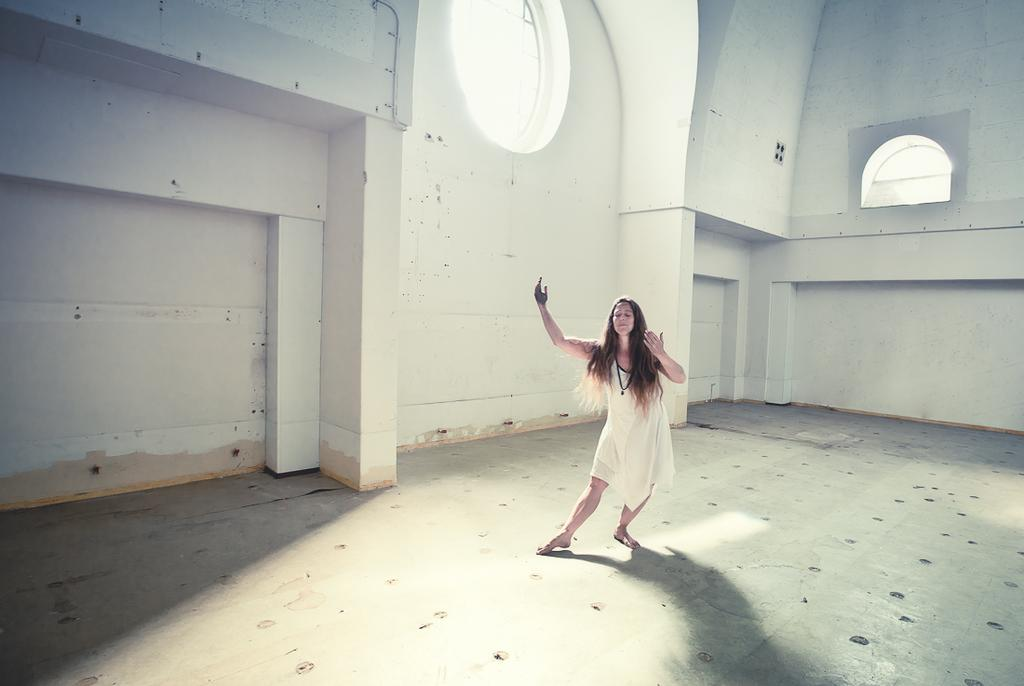Who is the main subject in the picture? There is a woman in the picture. What is the woman doing in the image? The woman is dancing. How many windows are visible in the room? The room has two windows. What type of boot is the woman wearing while dancing in the image? There is no mention of any boots in the image, and the woman's footwear is not visible. 